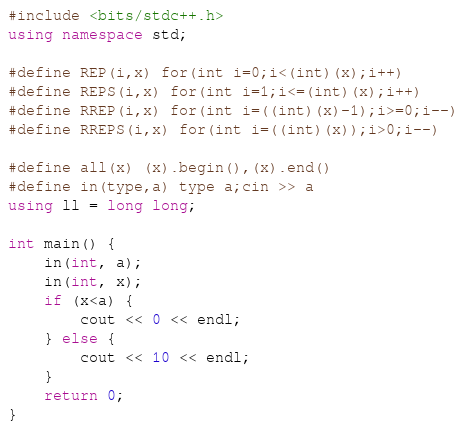<code> <loc_0><loc_0><loc_500><loc_500><_C++_>#include <bits/stdc++.h>
using namespace std;

#define REP(i,x) for(int i=0;i<(int)(x);i++)
#define REPS(i,x) for(int i=1;i<=(int)(x);i++)
#define RREP(i,x) for(int i=((int)(x)-1);i>=0;i--)
#define RREPS(i,x) for(int i=((int)(x));i>0;i--)

#define all(x) (x).begin(),(x).end()
#define in(type,a) type a;cin >> a
using ll = long long;

int main() {
    in(int, a);
    in(int, x);
    if (x<a) {
        cout << 0 << endl;
    } else {
        cout << 10 << endl;
    }
    return 0;
}
</code> 